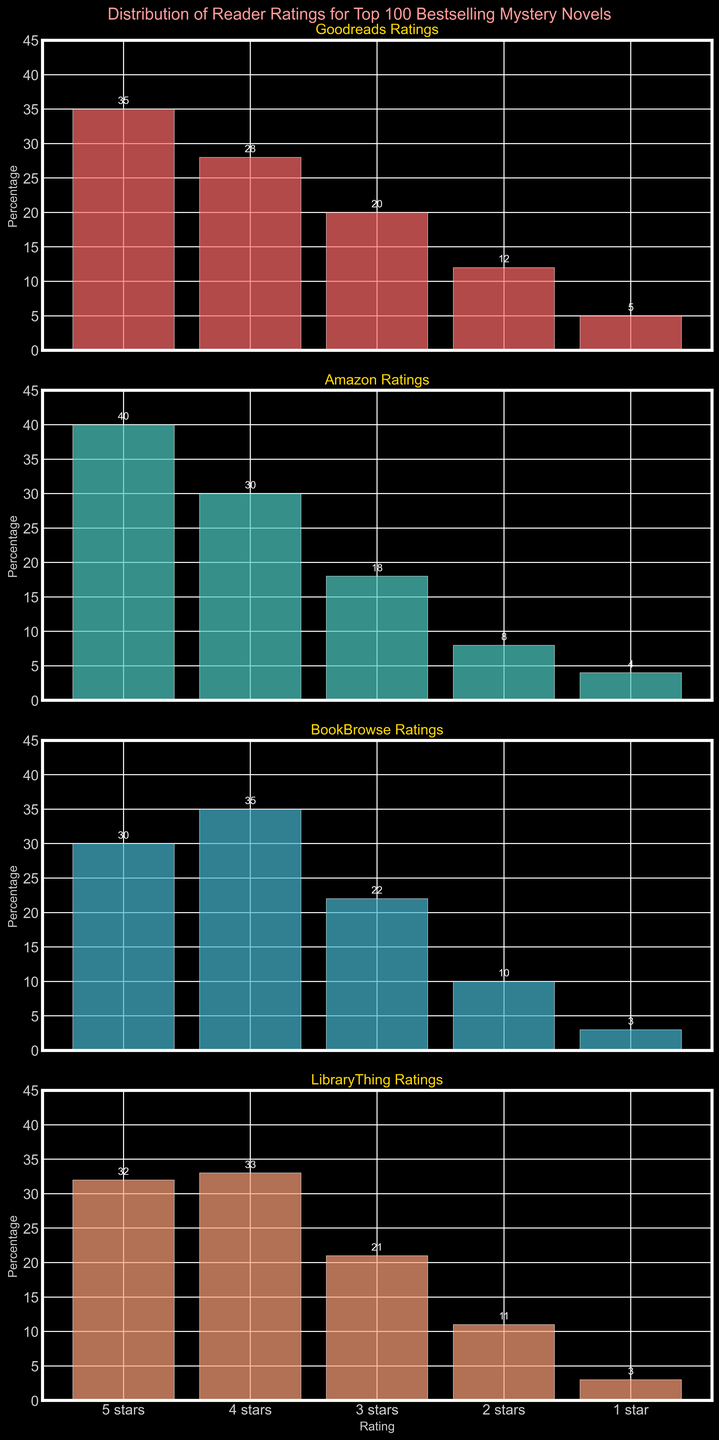What is the title of the plot? The title is displayed at the top of the plot in larger font size and pink color. It reads "Distribution of Reader Ratings for Top 100 Bestselling Mystery Novels".
Answer: Distribution of Reader Ratings for Top 100 Bestselling Mystery Novels What is the percentage of 5-star ratings on Goodreads? Look at the first subplot labeled 'Goodreads Ratings'. The bar for '5 stars' reaches the 35% mark and has a label on top confirming this value.
Answer: 35% Which platform has the most 4-star ratings? By comparing the 4-star rating bars in all subplots, BookBrowse has the tallest bar reaching 35%, indicated by the label on top.
Answer: BookBrowse How many more 3-star ratings does BookBrowse have compared to LibraryThing? BookBrowse has 22% 3-star ratings, while LibraryThing has 21%. The difference is calculated as 22 - 21 = 1%.
Answer: 1% Which platform shows the lowest percentage of 2-star ratings? By examining all subplots, Amazon has the lowest percentage for 2-star ratings at 8%, shown by the bar and its label.
Answer: Amazon What is the total percentage of 1-star ratings across all platforms? Sum the 1-star rating percentages for all platforms: 5% (Goodreads) + 4% (Amazon) + 3% (BookBrowse) + 3% (LibraryThing) = 15%.
Answer: 15% Compare the 5-star ratings between Amazon and Goodreads. Which platform has more, and by what percentage? Goodreads has 35% 5-star ratings, and Amazon has 40%. Calculate the difference: 40 - 35 = 5%. Amazon has 5% more 5-star ratings.
Answer: Amazon by 5% If you average the 4-star ratings across all platforms, what is the result? Sum the 4-star ratings percentages across all platforms and divide by the number of platforms: (28 + 30 + 35 + 33)/4 = 126/4. The average is 31.5%.
Answer: 31.5% Which rating category has the least variation across the platforms? Observe each rating category across all subplots. The 1-star ratings vary the least: 5% (Goodreads), 4% (Amazon), 3% (BookBrowse), and 3% (LibraryThing), a variation range of only 2%.
Answer: 1-star ratings 